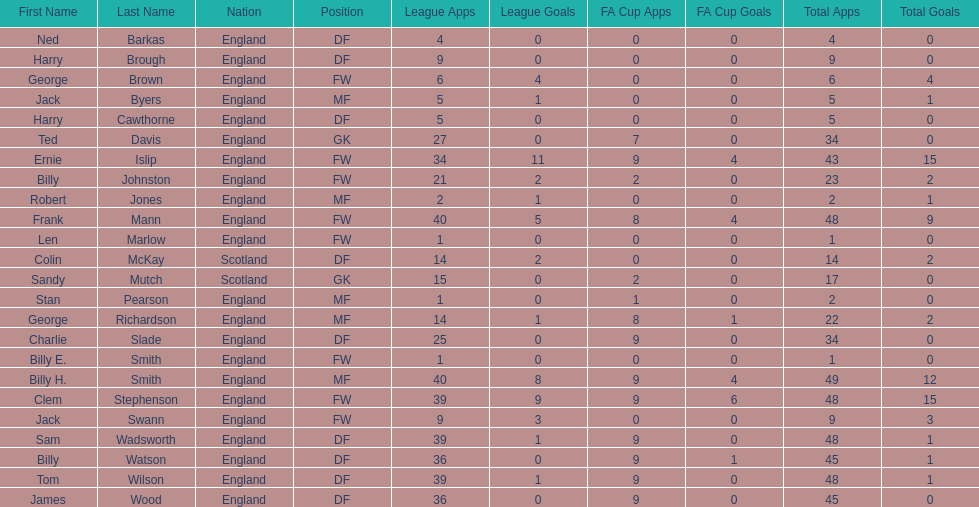Could you parse the entire table? {'header': ['First Name', 'Last Name', 'Nation', 'Position', 'League Apps', 'League Goals', 'FA Cup Apps', 'FA Cup Goals', 'Total Apps', 'Total Goals'], 'rows': [['Ned', 'Barkas', 'England', 'DF', '4', '0', '0', '0', '4', '0'], ['Harry', 'Brough', 'England', 'DF', '9', '0', '0', '0', '9', '0'], ['George', 'Brown', 'England', 'FW', '6', '4', '0', '0', '6', '4'], ['Jack', 'Byers', 'England', 'MF', '5', '1', '0', '0', '5', '1'], ['Harry', 'Cawthorne', 'England', 'DF', '5', '0', '0', '0', '5', '0'], ['Ted', 'Davis', 'England', 'GK', '27', '0', '7', '0', '34', '0'], ['Ernie', 'Islip', 'England', 'FW', '34', '11', '9', '4', '43', '15'], ['Billy', 'Johnston', 'England', 'FW', '21', '2', '2', '0', '23', '2'], ['Robert', 'Jones', 'England', 'MF', '2', '1', '0', '0', '2', '1'], ['Frank', 'Mann', 'England', 'FW', '40', '5', '8', '4', '48', '9'], ['Len', 'Marlow', 'England', 'FW', '1', '0', '0', '0', '1', '0'], ['Colin', 'McKay', 'Scotland', 'DF', '14', '2', '0', '0', '14', '2'], ['Sandy', 'Mutch', 'Scotland', 'GK', '15', '0', '2', '0', '17', '0'], ['Stan', 'Pearson', 'England', 'MF', '1', '0', '1', '0', '2', '0'], ['George', 'Richardson', 'England', 'MF', '14', '1', '8', '1', '22', '2'], ['Charlie', 'Slade', 'England', 'DF', '25', '0', '9', '0', '34', '0'], ['Billy E.', 'Smith', 'England', 'FW', '1', '0', '0', '0', '1', '0'], ['Billy H.', 'Smith', 'England', 'MF', '40', '8', '9', '4', '49', '12'], ['Clem', 'Stephenson', 'England', 'FW', '39', '9', '9', '6', '48', '15'], ['Jack', 'Swann', 'England', 'FW', '9', '3', '0', '0', '9', '3'], ['Sam', 'Wadsworth', 'England', 'DF', '39', '1', '9', '0', '48', '1'], ['Billy', 'Watson', 'England', 'DF', '36', '0', '9', '1', '45', '1'], ['Tom', 'Wilson', 'England', 'DF', '39', '1', '9', '0', '48', '1'], ['James', 'Wood', 'England', 'DF', '36', '0', '9', '0', '45', '0']]} The least number of total appearances 1. 